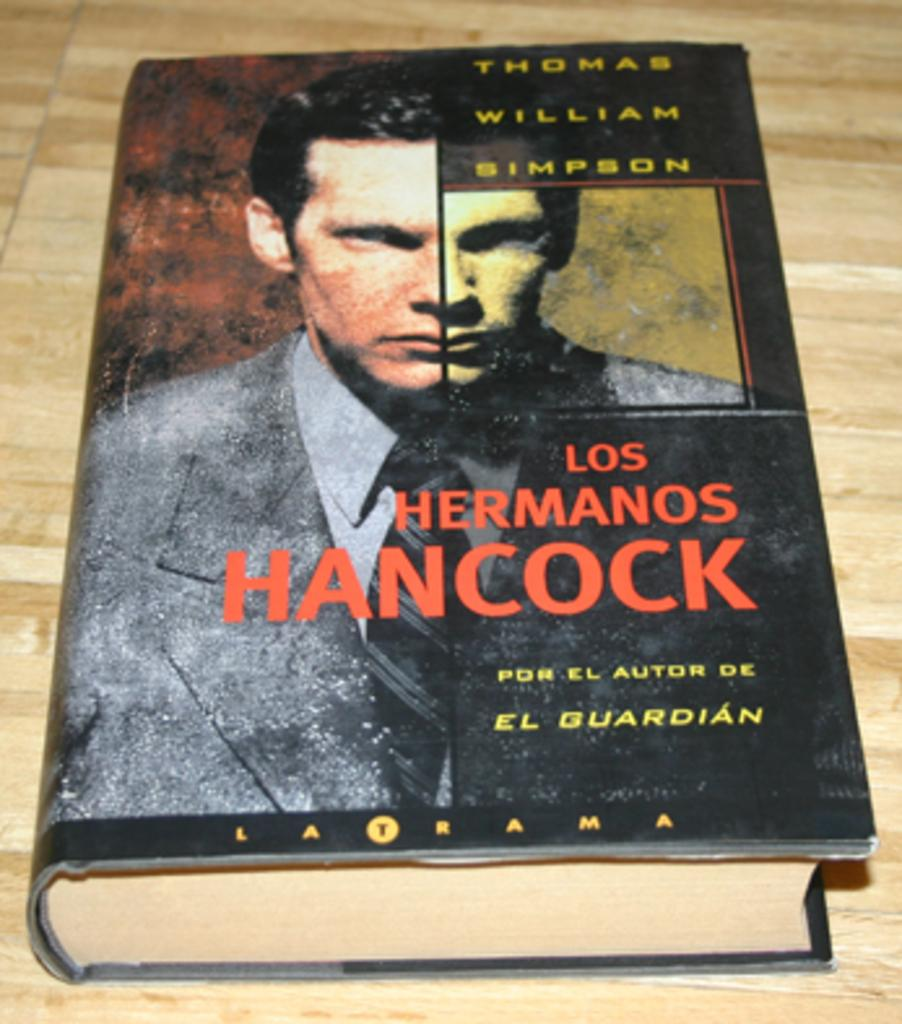<image>
Share a concise interpretation of the image provided. The book Los Hermanos Hancock sitting on a table. 